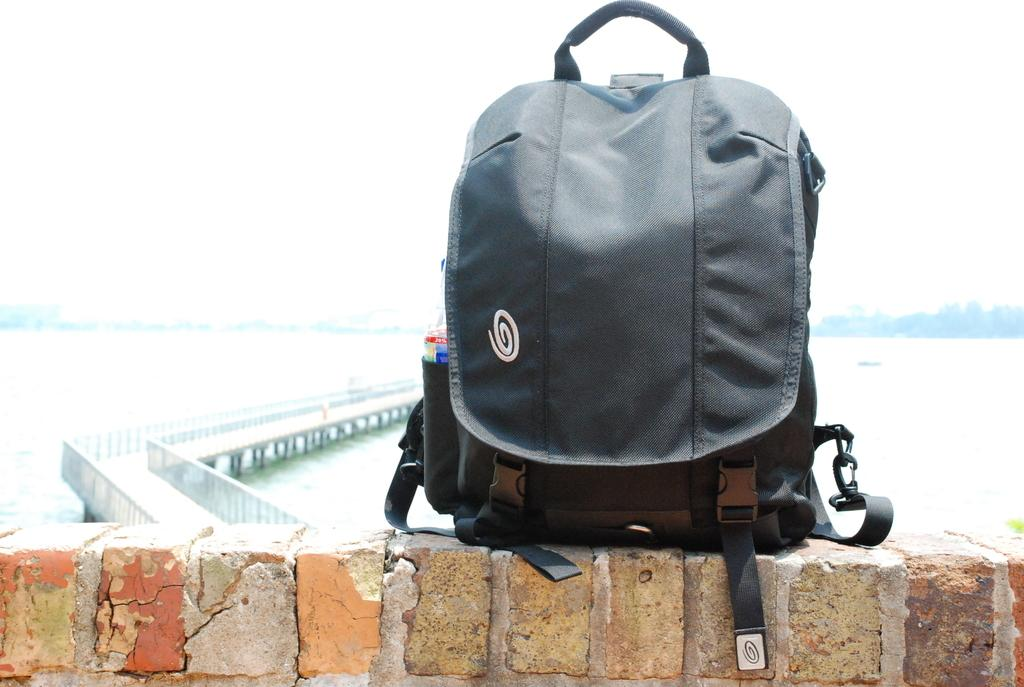What is the color of the bag in the image? The bag in the image is black. Where is the bag located? The bag is on a wall. What can be seen in the background of the image? There is a bridge, water, and the sky visible in the background of the image. What type of stamp can be seen on the bag in the image? There is no stamp visible on the bag in the image. Which actor is standing on the bridge in the background of the image? There are no actors present in the image, and the bridge is in the background. 